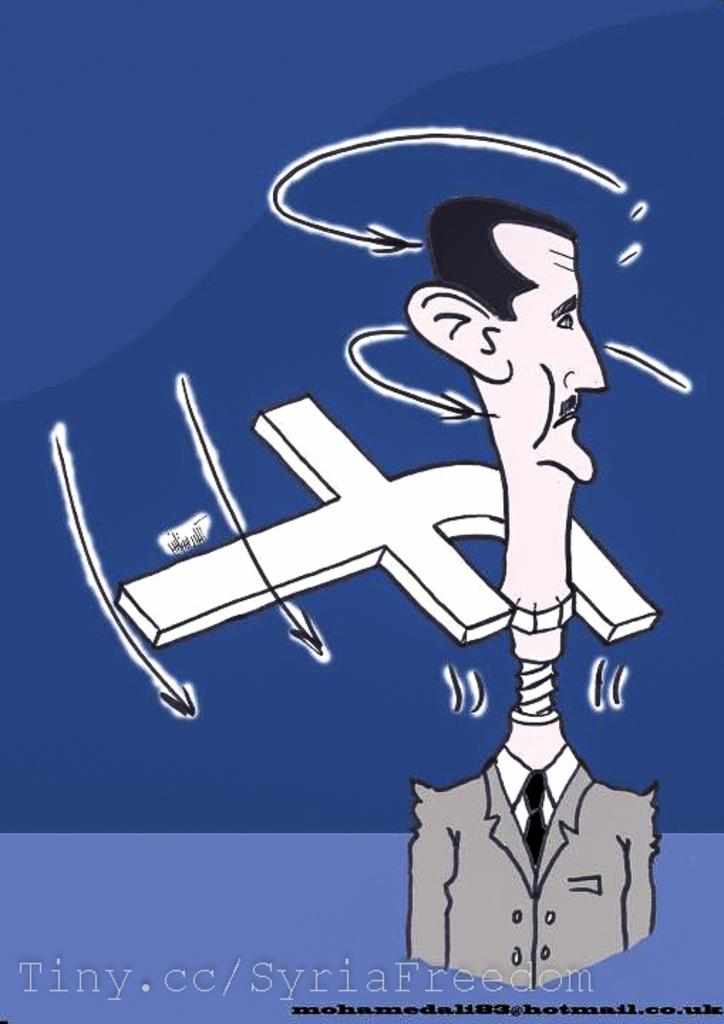<image>
Offer a succinct explanation of the picture presented. A political cartoon of a mans head being unscrewed by the facebook logo. 